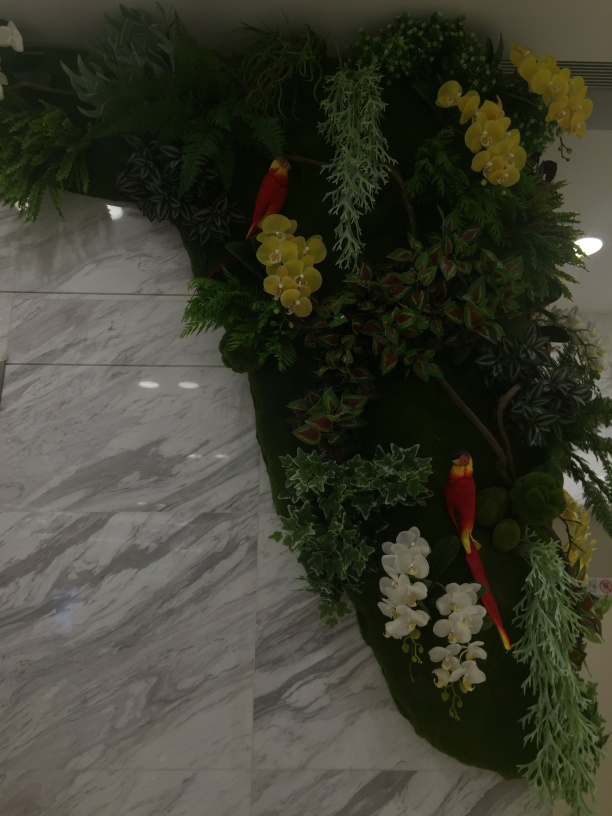What is the overall sharpness of this image?
A. Poor
B. High
C. Acceptable
Answer with the option's letter from the given choices directly. The overall sharpness of this image is acceptable, given the conditions of the image presented. While there's some clarity in the floral arrangement and the reflection on the marble floor, the lighting and the subtle blur could affect the sharpness, making it less than optimal for high sharpness but sufficiently clear for general viewing. 